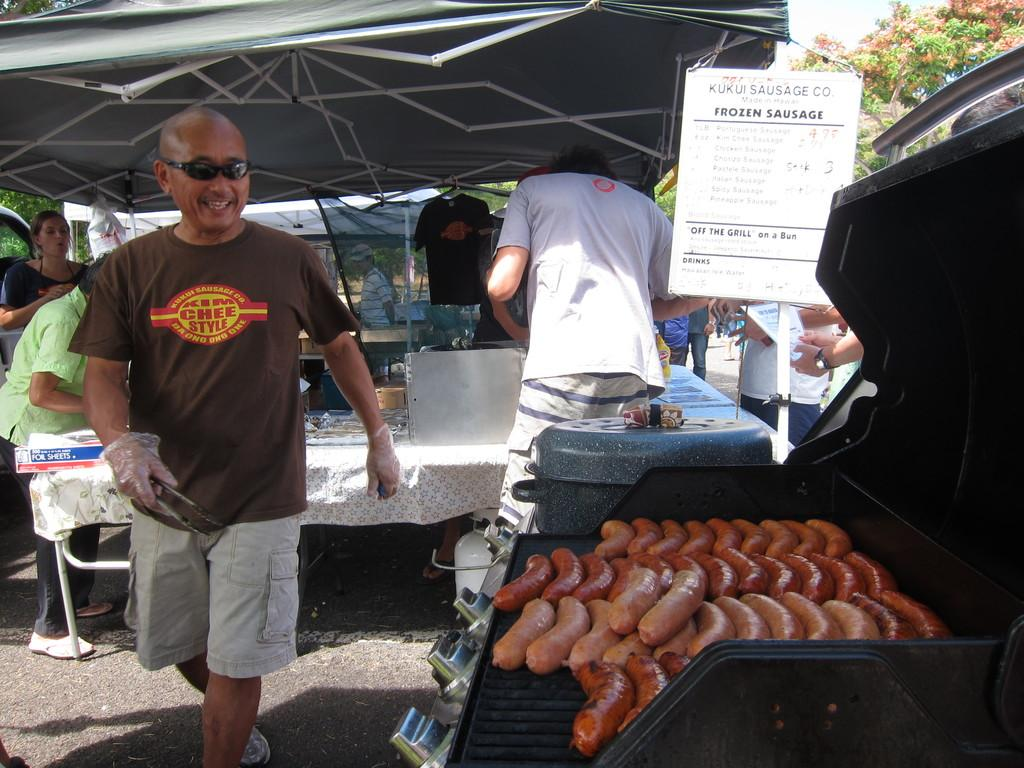What can be seen in the image involving people? There are people standing in the image. What is being cooked on the stove in the image? There are sausages on the stove in the image. What objects are present on the table in the image? There are vessels on a table in the image. What type of natural scenery is visible in the image? Trees are visible in the image. What is the board used for in the image? There is a board in the image, but its purpose is not clear from the facts provided. What type of temporary shelters can be seen in the image? There are tents in the image. What type of goldfish can be seen swimming in the image? There is no goldfish present in the image. How many selections are available for the people in the image? The facts provided do not mention any selections or choices for the people in the image. What type of transportation is visible at the airport in the image? There is no airport or transportation visible in the image. 